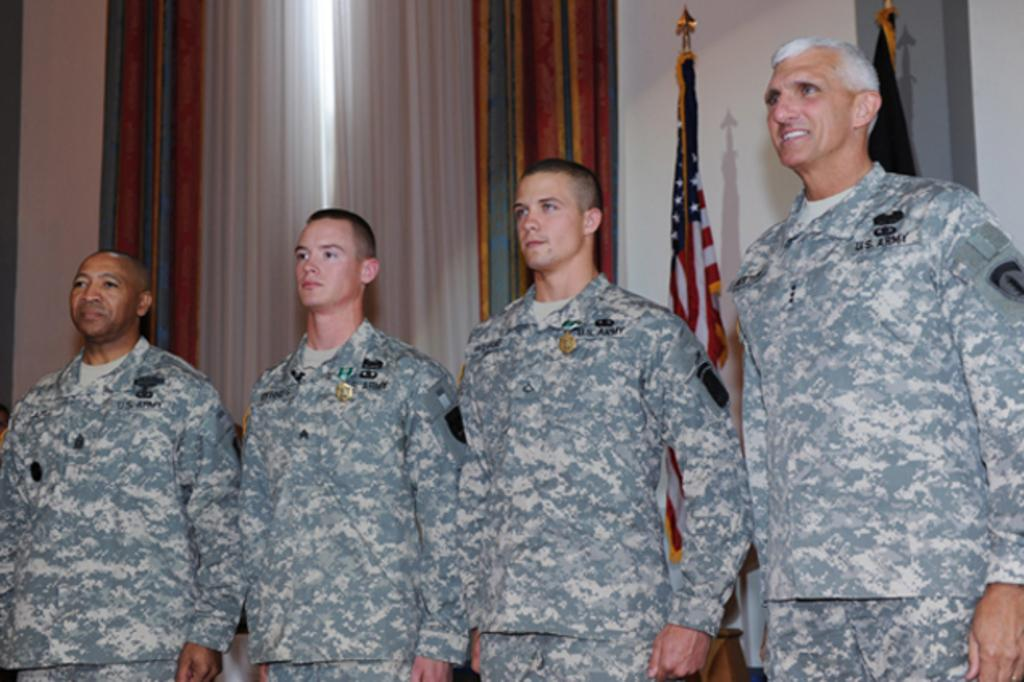How many people are in the image? There are four men in the image. What can be seen hanging in the background of the image? Curtains are visible in the image. What additional elements are present in the image? There are flags in the image. What type of beast can be seen swimming near the dock in the image? There is no dock or beast present in the image. 